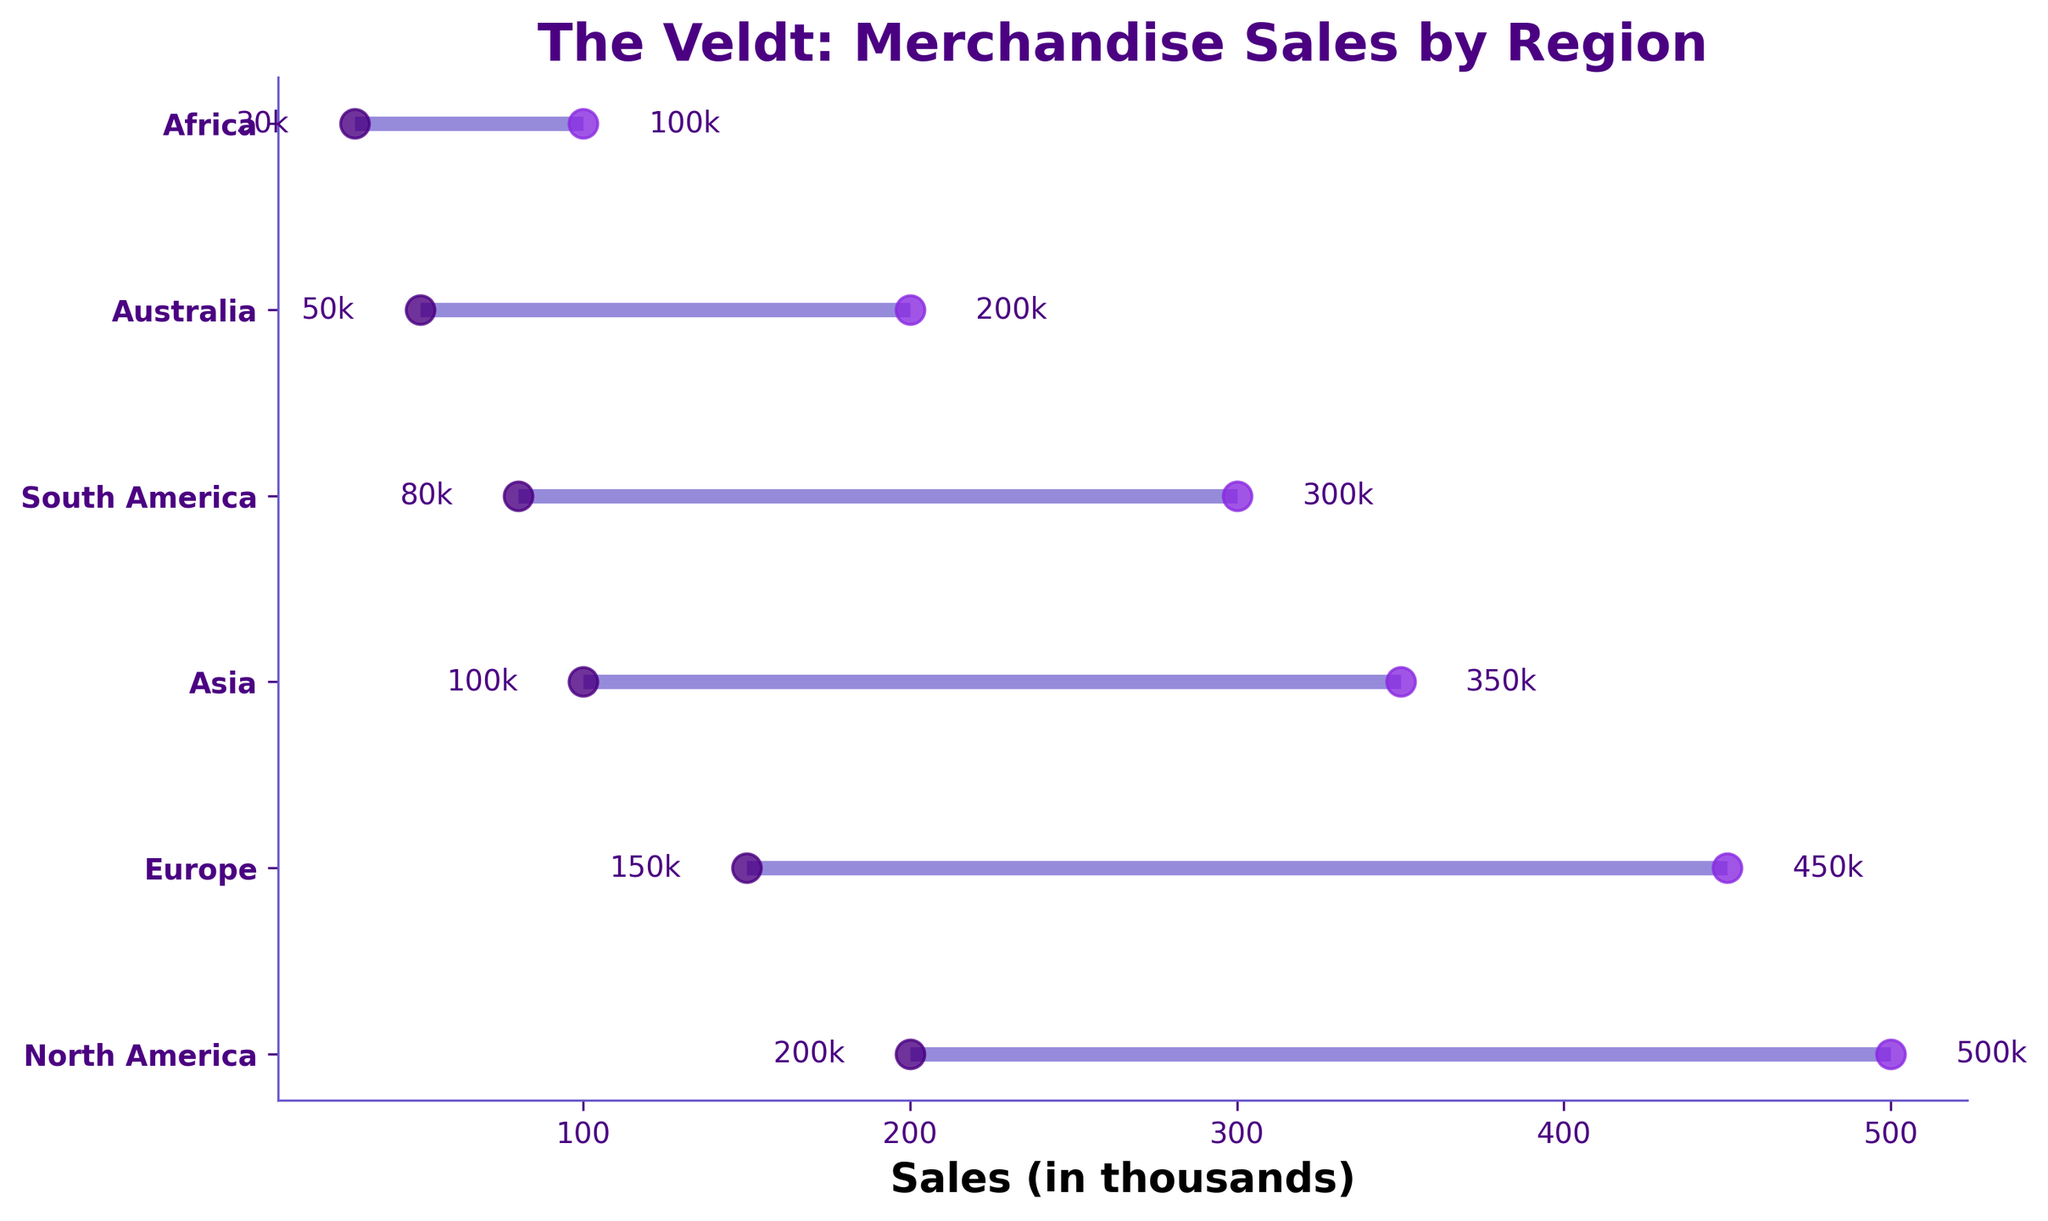What's the title of the plot? The title is located at the top of the plot. It's written in a bold and larger font.
Answer: The Veldt: Merchandise Sales by Region How many regions are displayed in the plot? Count the number of data points or lines on the y-axis representing regions.
Answer: 6 Which region has the highest maximum sales? Locate the region with the highest rightmost dot on the x-axis.
Answer: North America What is the range of merchandise sales in Asia? Find the minimum and maximum sales values for Asia and subtract the minimum value from the maximum value.
Answer: 250 Which region has the smallest range of merchandise sales? Compare the length of the horizontal lines across all regions to find the shortest one.
Answer: Africa What is the average maximum sales in Europe and Asia? Add the maximum sales values for Europe and Asia and divide by 2.
Answer: 400 By how much do the maximum sales of North America exceed those of South America? Subtract the maximum sales of South America from those of North America.
Answer: 200 In which regions are the minimum sales less than 100? Identify regions where the leftmost dot on the x-axis is less than 100.
Answer: Australia and Africa What are the minimum and maximum sales values in South America? Look at the two dots representing South America on the x-axis.
Answer: 80k and 300k Which region has sales more than 200k but less than 500k? Identify regions where the sales fall in the range between 200k and 500k.
Answer: North America, Europe, and Asia 